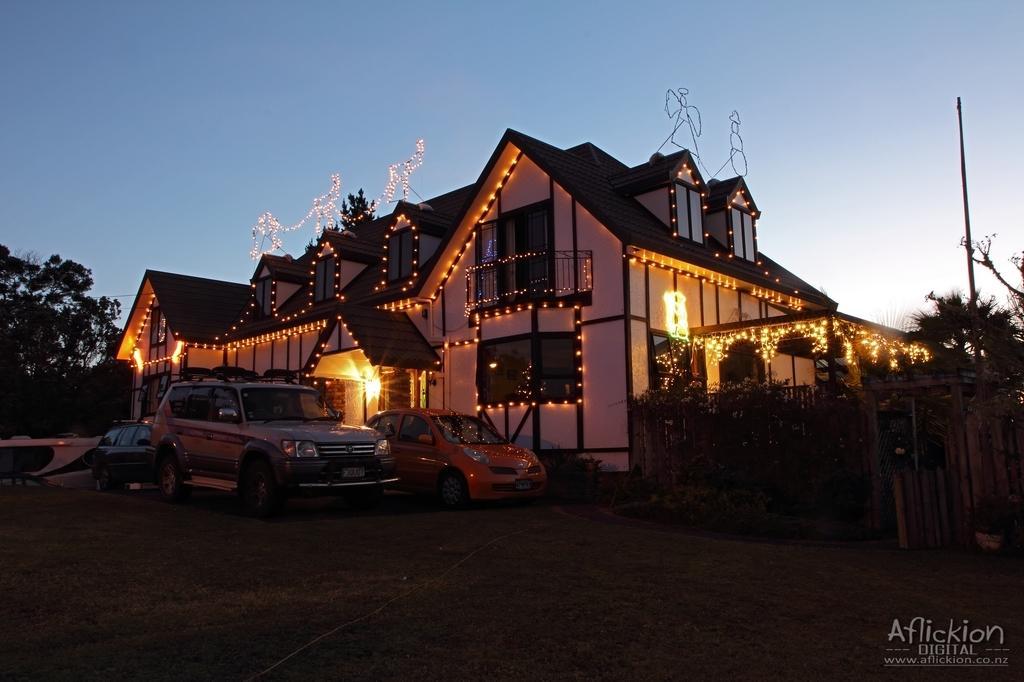Can you describe this image briefly? In the image we can see there are cars parked on the ground and there is a building which is decorated with lights. There are trees and there is clear sky. 